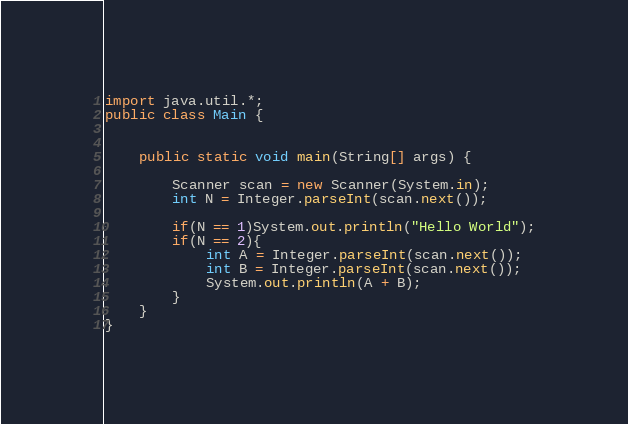Convert code to text. <code><loc_0><loc_0><loc_500><loc_500><_Java_>import java.util.*;
public class Main {


    public static void main(String[] args) {

        Scanner scan = new Scanner(System.in);
        int N = Integer.parseInt(scan.next());

        if(N == 1)System.out.println("Hello World");
        if(N == 2){
            int A = Integer.parseInt(scan.next());
            int B = Integer.parseInt(scan.next());
            System.out.println(A + B);
        }
    }
}
</code> 